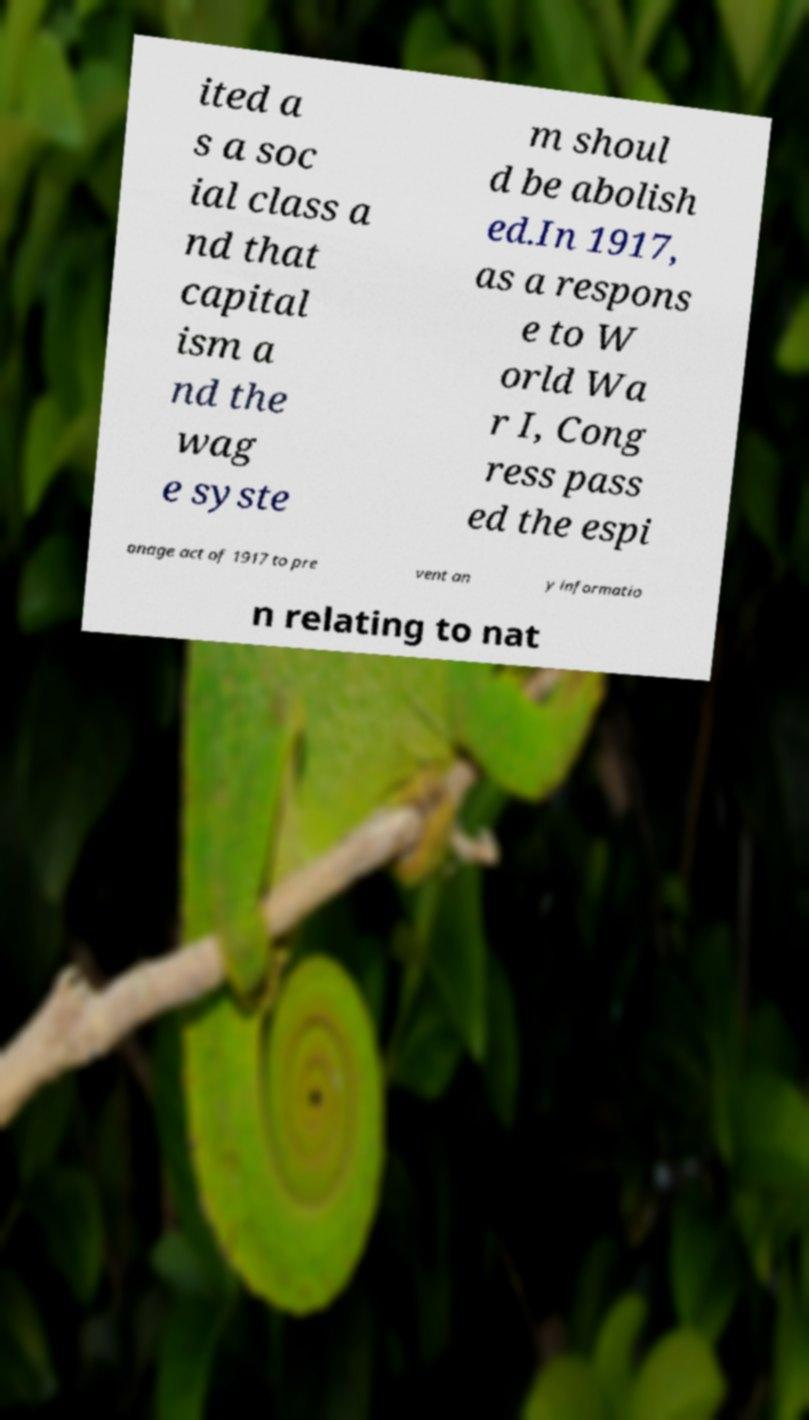I need the written content from this picture converted into text. Can you do that? ited a s a soc ial class a nd that capital ism a nd the wag e syste m shoul d be abolish ed.In 1917, as a respons e to W orld Wa r I, Cong ress pass ed the espi onage act of 1917 to pre vent an y informatio n relating to nat 